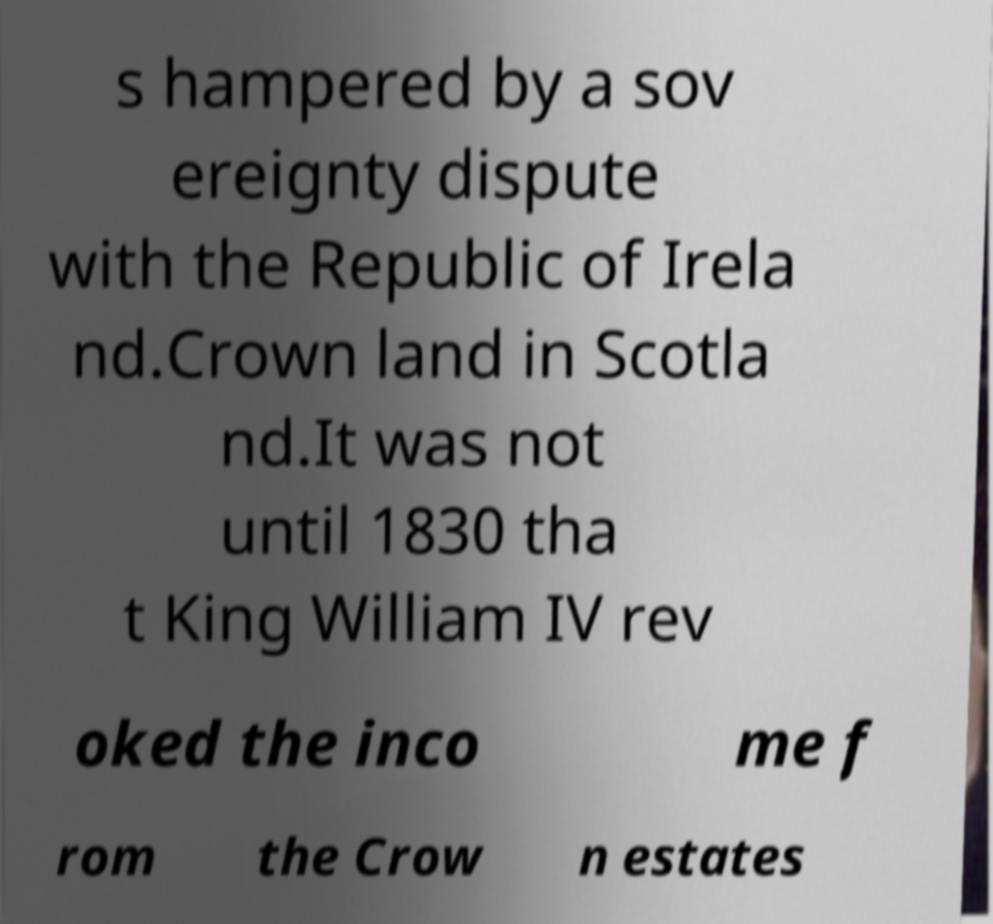There's text embedded in this image that I need extracted. Can you transcribe it verbatim? s hampered by a sov ereignty dispute with the Republic of Irela nd.Crown land in Scotla nd.It was not until 1830 tha t King William IV rev oked the inco me f rom the Crow n estates 